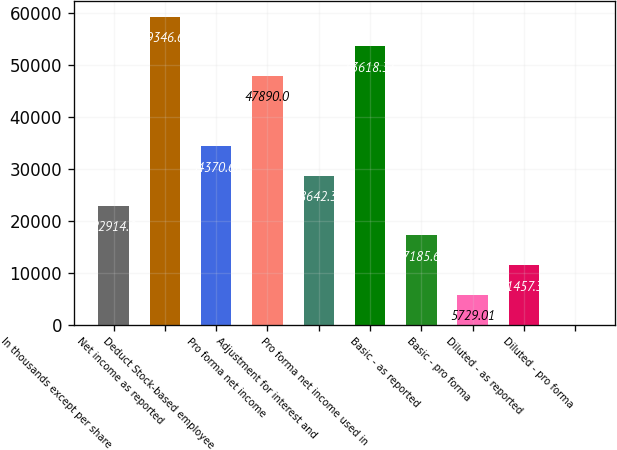<chart> <loc_0><loc_0><loc_500><loc_500><bar_chart><fcel>In thousands except per share<fcel>Net income as reported<fcel>Deduct Stock-based employee<fcel>Pro forma net income<fcel>Adjustment for interest and<fcel>Pro forma net income used in<fcel>Basic - as reported<fcel>Basic - pro forma<fcel>Diluted - as reported<fcel>Diluted - pro forma<nl><fcel>22914<fcel>59346.7<fcel>34370.7<fcel>47890<fcel>28642.3<fcel>53618.3<fcel>17185.7<fcel>5729.01<fcel>11457.3<fcel>0.68<nl></chart> 